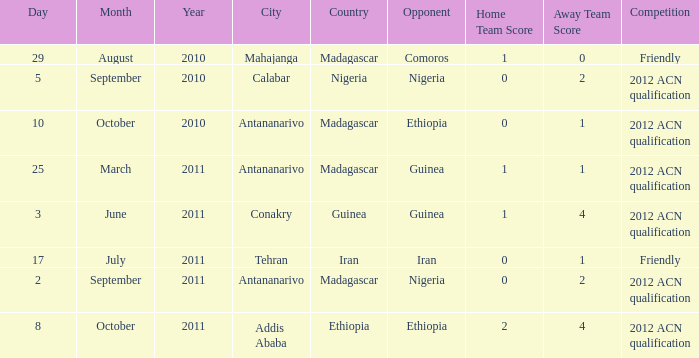What is the score at the Addis Ababa location? 2-4. 